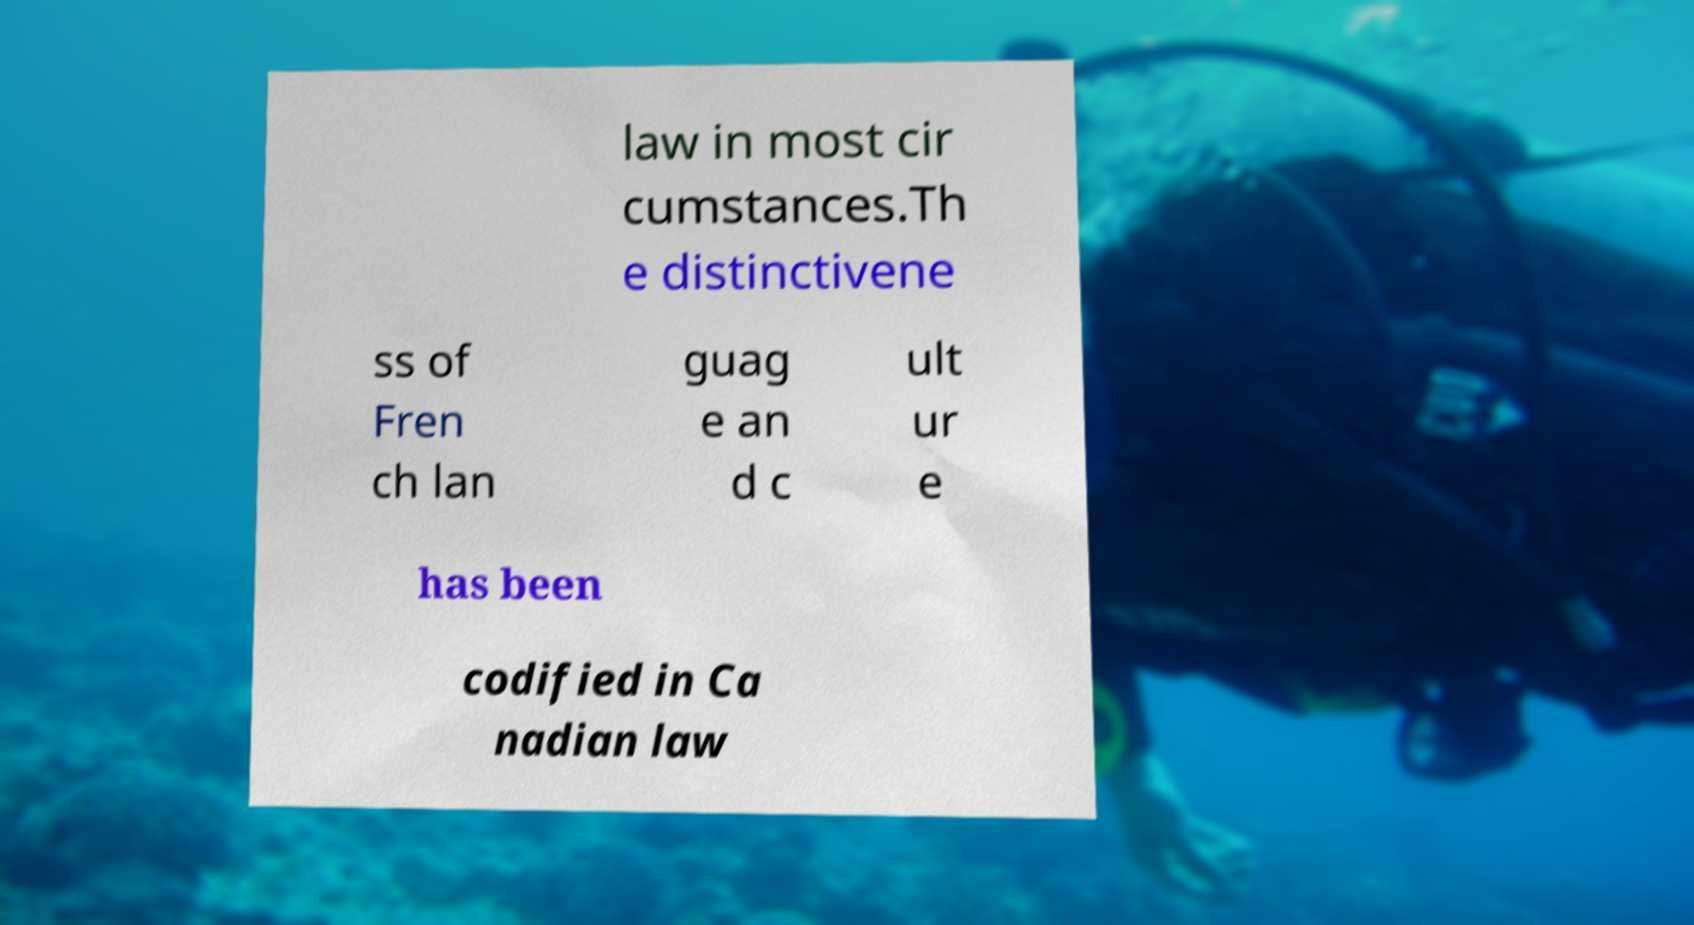There's text embedded in this image that I need extracted. Can you transcribe it verbatim? law in most cir cumstances.Th e distinctivene ss of Fren ch lan guag e an d c ult ur e has been codified in Ca nadian law 